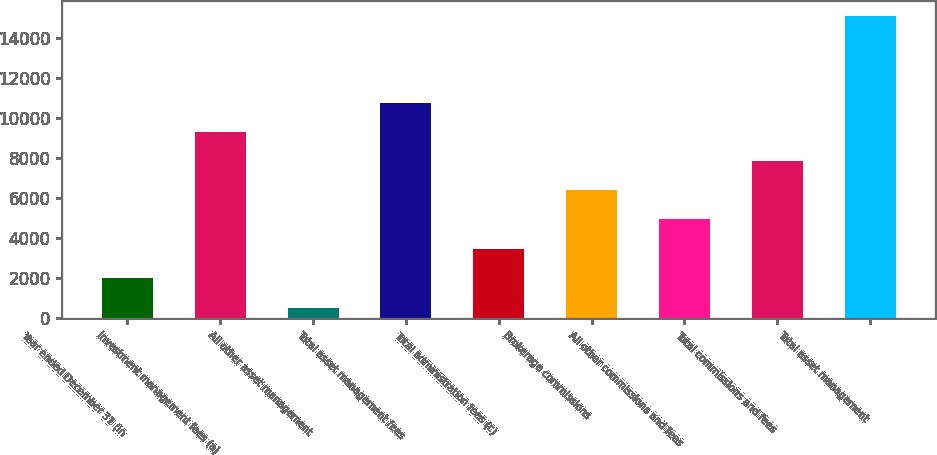Convert chart to OTSL. <chart><loc_0><loc_0><loc_500><loc_500><bar_chart><fcel>Year ended December 31 (in<fcel>Investment management fees (a)<fcel>All other asset management<fcel>Total asset management fees<fcel>Total administration fees (c)<fcel>Brokerage commissions<fcel>All other commissions and fees<fcel>Total commissions and fees<fcel>Total asset management<nl><fcel>2013<fcel>9313.5<fcel>505<fcel>10773.6<fcel>3473.1<fcel>6393.3<fcel>4933.2<fcel>7853.4<fcel>15106<nl></chart> 